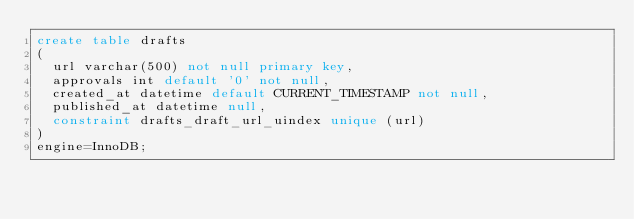Convert code to text. <code><loc_0><loc_0><loc_500><loc_500><_SQL_>create table drafts
(
	url varchar(500) not null primary key,
	approvals int default '0' not null,
	created_at datetime default CURRENT_TIMESTAMP not null,
	published_at datetime null,
	constraint drafts_draft_url_uindex unique (url)
)
engine=InnoDB;</code> 